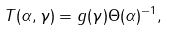Convert formula to latex. <formula><loc_0><loc_0><loc_500><loc_500>T ( \alpha , \gamma ) = g ( \gamma ) \Theta ( \alpha ) ^ { - 1 } ,</formula> 